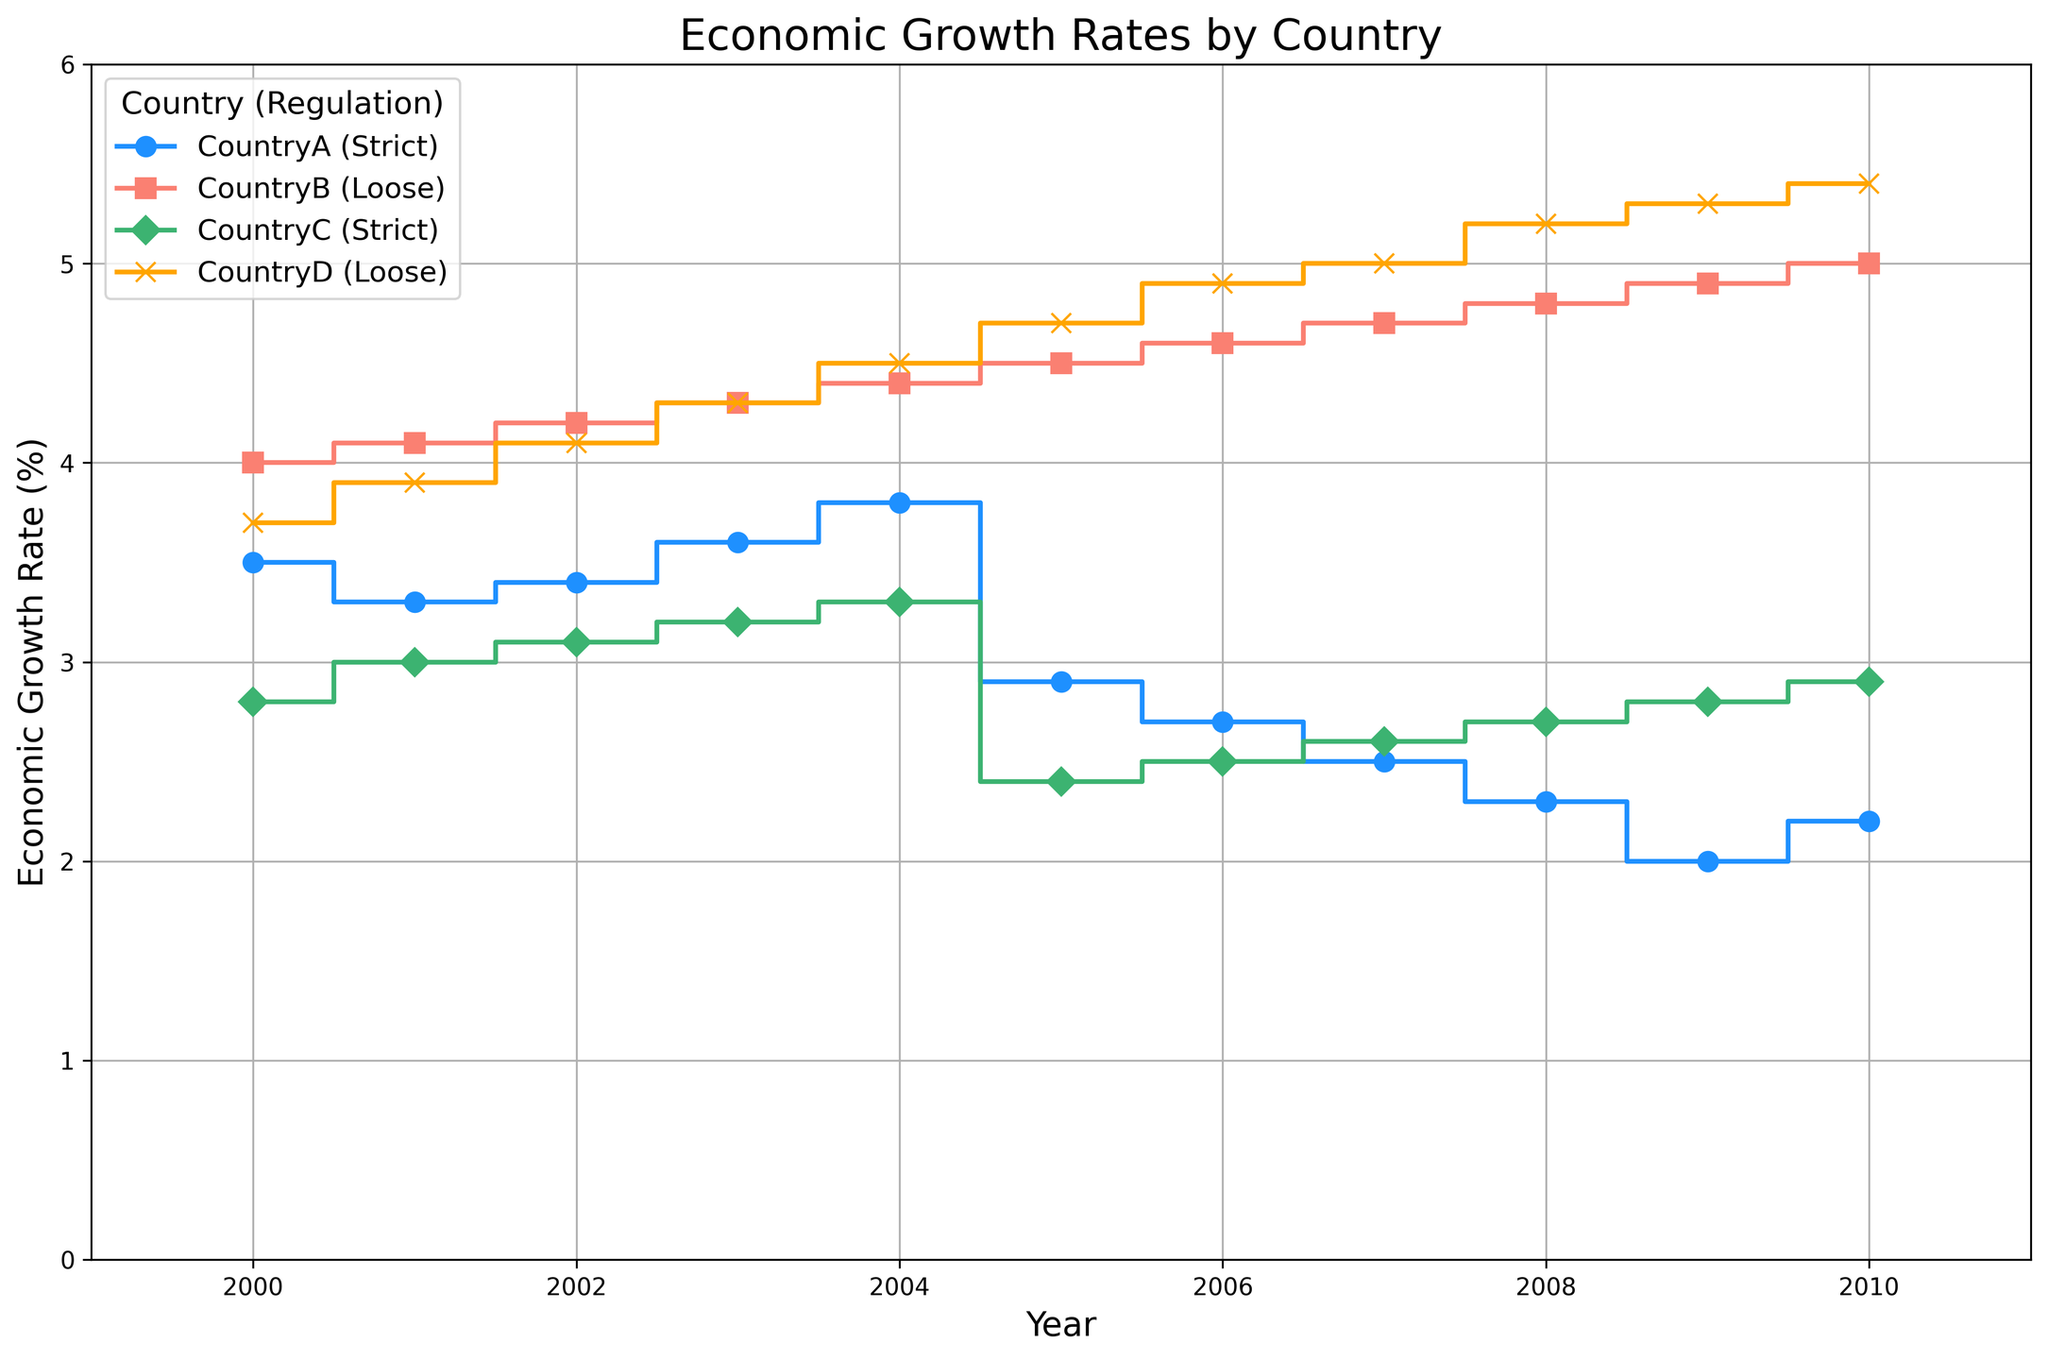Which country had the highest economic growth rate in 2010? To determine the highest economic growth rate in 2010, observe the endpoints of each step plot for that year. Country B and Country D had the highest rates, both at 5.0 and 5.4 respectively. However, Country D had the highest with 5.4.
Answer: Country D What is the difference in economic growth rate between Country A (Strict) and Country B (Loose) in 2005? In 2005, Country A had an economic growth rate of 2.9, and Country B had a rate of 4.5. The difference is calculated as 4.5 - 2.9.
Answer: 1.6 How many years did Country B exhibit continuous growth without any decline? To identify continuous growth, observe the step plot for Country B. Starting from 2000 to 2010, Country B’s economic growth rate consistently increased each year.
Answer: 11 years Which countries have economic growth rates above 3% after 2008? From the step plot, observe the economic growth rates after 2008. Both Country B and Country D maintained rates above 3%, while Country A and Country C kept below 3%.
Answer: Country B and Country D On average, which regulation type (Strict or Loose) showed higher economic growth rates across all countries? First, calculate the average economic growth rates for each regulation type: Strict (Country A and Country C) and Loose (Country B and Country D). Compare the sums and their total years. Loose regulations showed higher rates.
Answer: Loose 